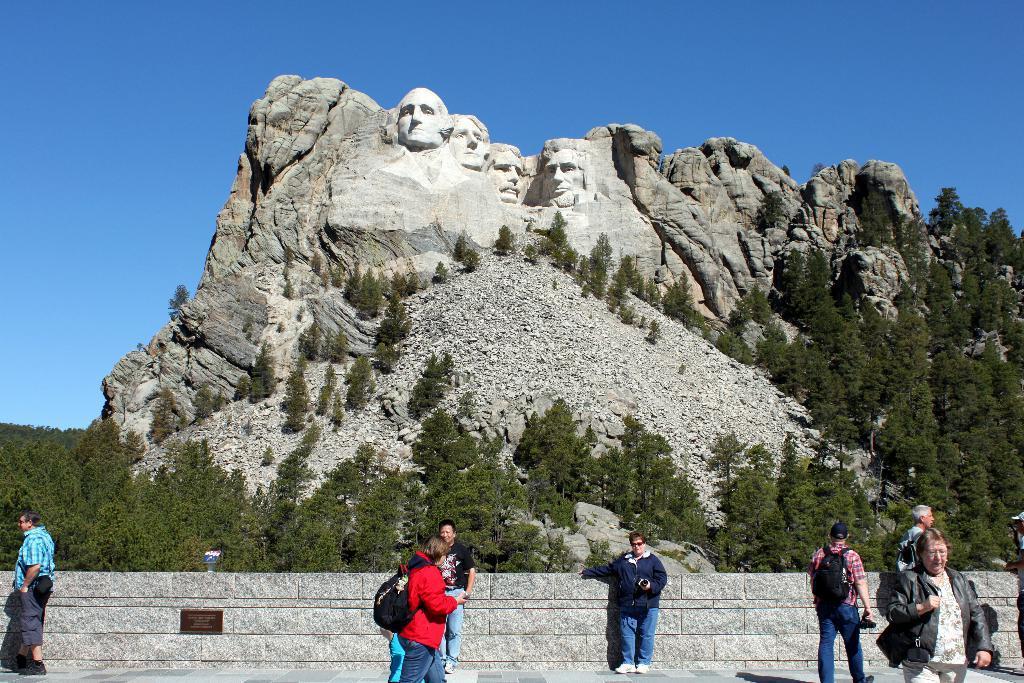Can you describe this image briefly? In this image there are engravings on the stone. At the bottom there are few people who are walking on the floor. In the background there is a stone wall. Behind the wall there are trees. At the top there is the sky. 